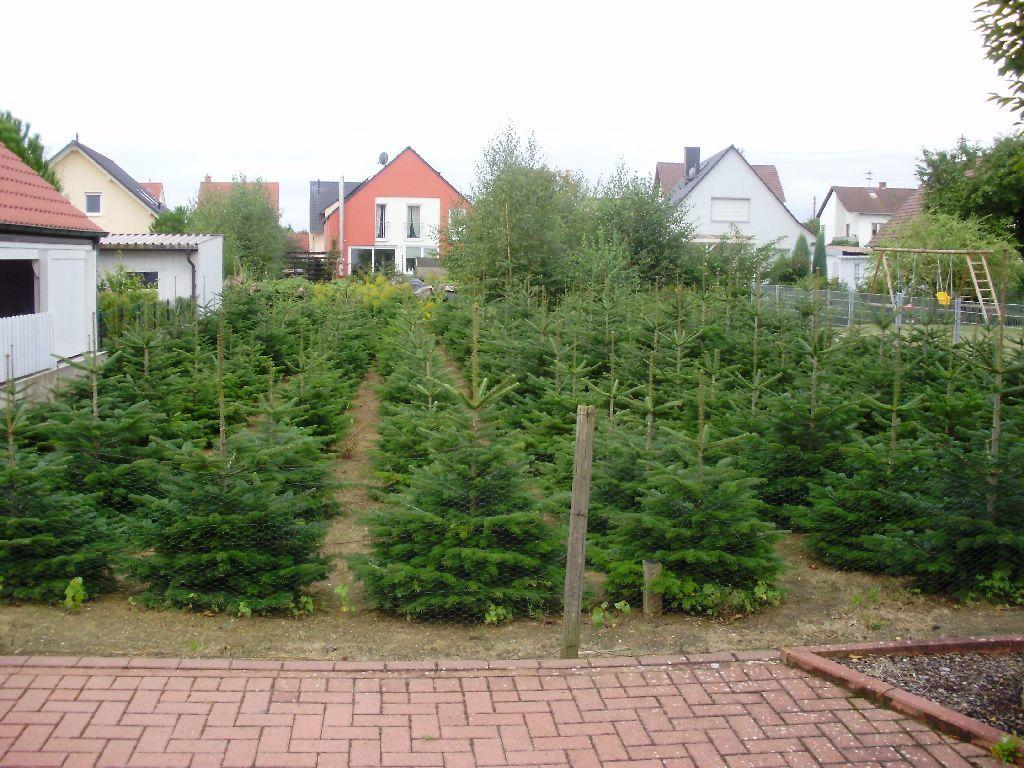What type of vegetation is on the ground in the image? There are plants on the ground in the image. What structures can be seen in the background of the image? There are houses in the background of the image. What type of natural features are visible in the image? There are trees visible in the image. What is visible at the top of the image? The sky is visible at the top of the image. What type of sound can be heard coming from the bears in the image? There are no bears present in the image, so it is not possible to determine what sound they might be making. 